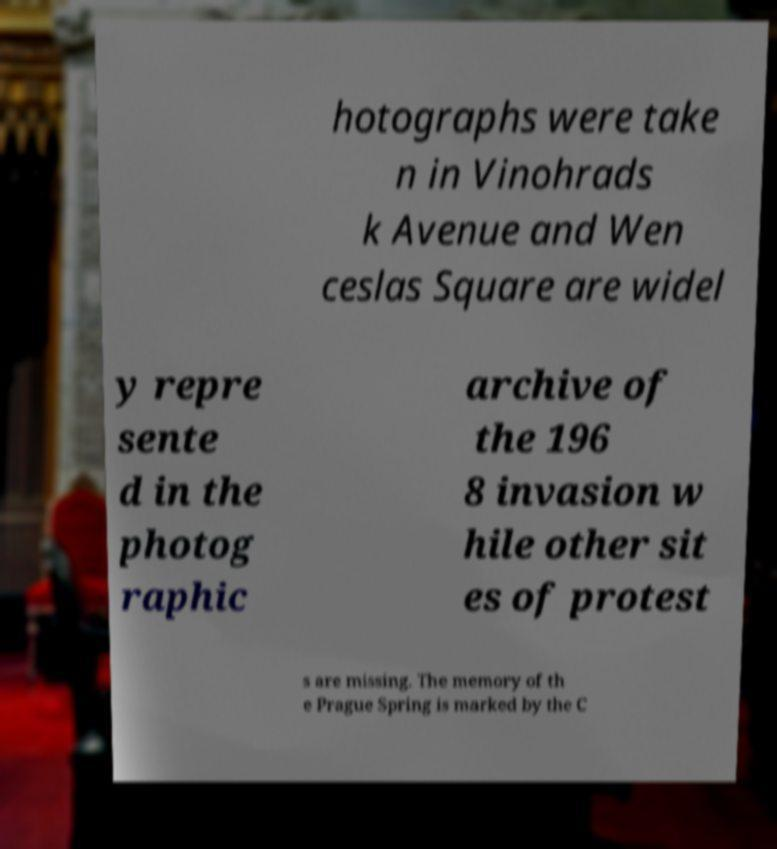There's text embedded in this image that I need extracted. Can you transcribe it verbatim? hotographs were take n in Vinohrads k Avenue and Wen ceslas Square are widel y repre sente d in the photog raphic archive of the 196 8 invasion w hile other sit es of protest s are missing. The memory of th e Prague Spring is marked by the C 